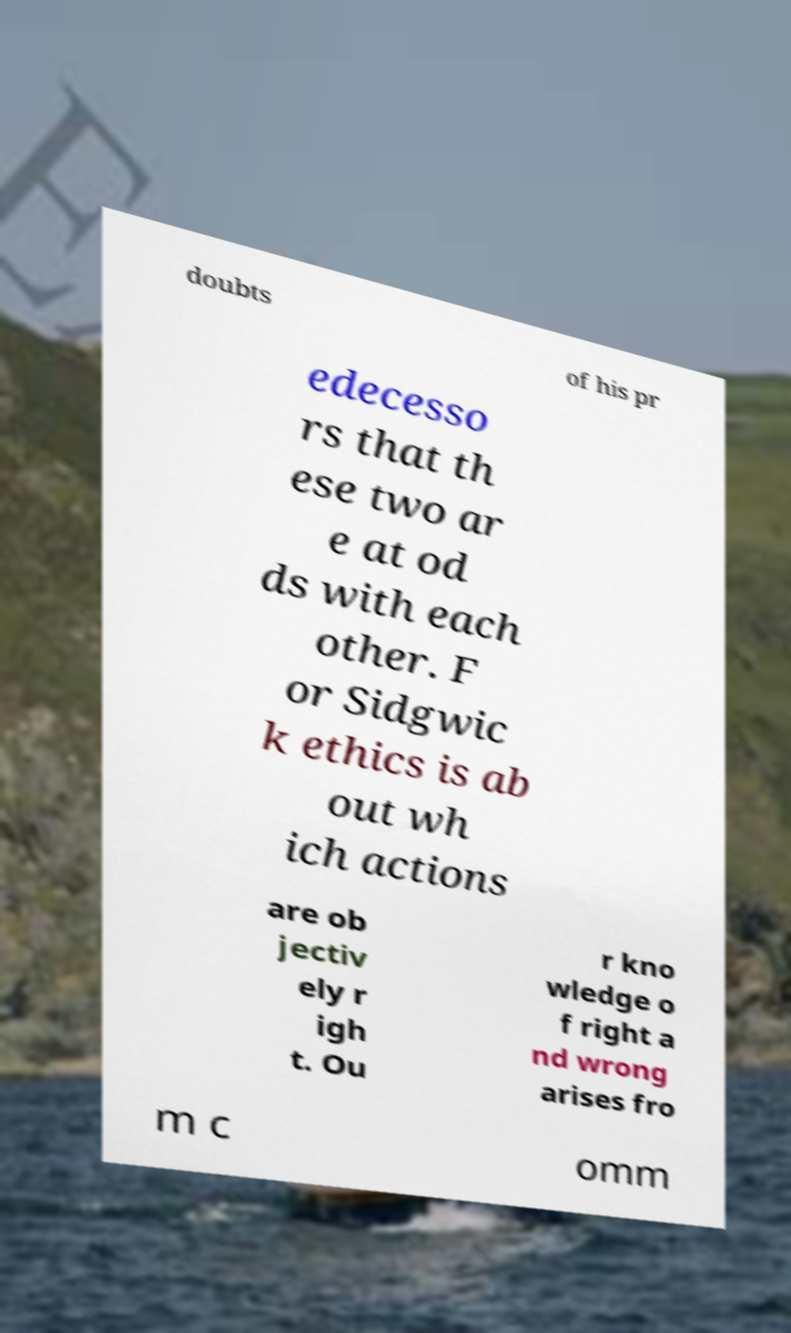Please identify and transcribe the text found in this image. doubts of his pr edecesso rs that th ese two ar e at od ds with each other. F or Sidgwic k ethics is ab out wh ich actions are ob jectiv ely r igh t. Ou r kno wledge o f right a nd wrong arises fro m c omm 